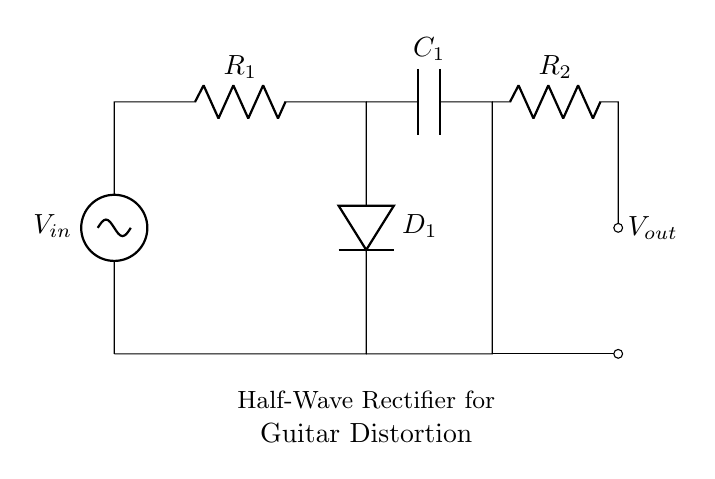What is the purpose of D1 in this circuit? D1 is a diode that allows current to flow in only one direction, converting the AC input voltage into a pulsating DC output, which is essential for the rectifier function.
Answer: diode What type of rectifier is shown in the circuit? The circuit is a half-wave rectifier, which means it only allows one half of the wave (positive or negative) to pass through while blocking the other half, resulting in pulsating DC output.
Answer: half-wave What is the role of R1 in the circuit? R1 acts as a current limiting resistor for the input voltage, controlling the amount of current flowing into D1 and protecting it from excessive current.
Answer: current limiting resistor What is the value of the output voltage as visualized? The output voltage, labeled as Vout, is taken across R2 and will display a pulsating waveform corresponding to the input's positive half-cycles.
Answer: pulsating DC How many capacitors are present in the circuit? There is one capacitor (C1), which is used to smooth the pulsating DC output and reduce ripple voltage, enhancing the quality of the signal.
Answer: one What is the effect of C1 on Vout? C1 smooths the output voltage by charging during the high peaks and discharging during the low peaks, thus reducing ripple and making the output voltage more stable.
Answer: smoothing 